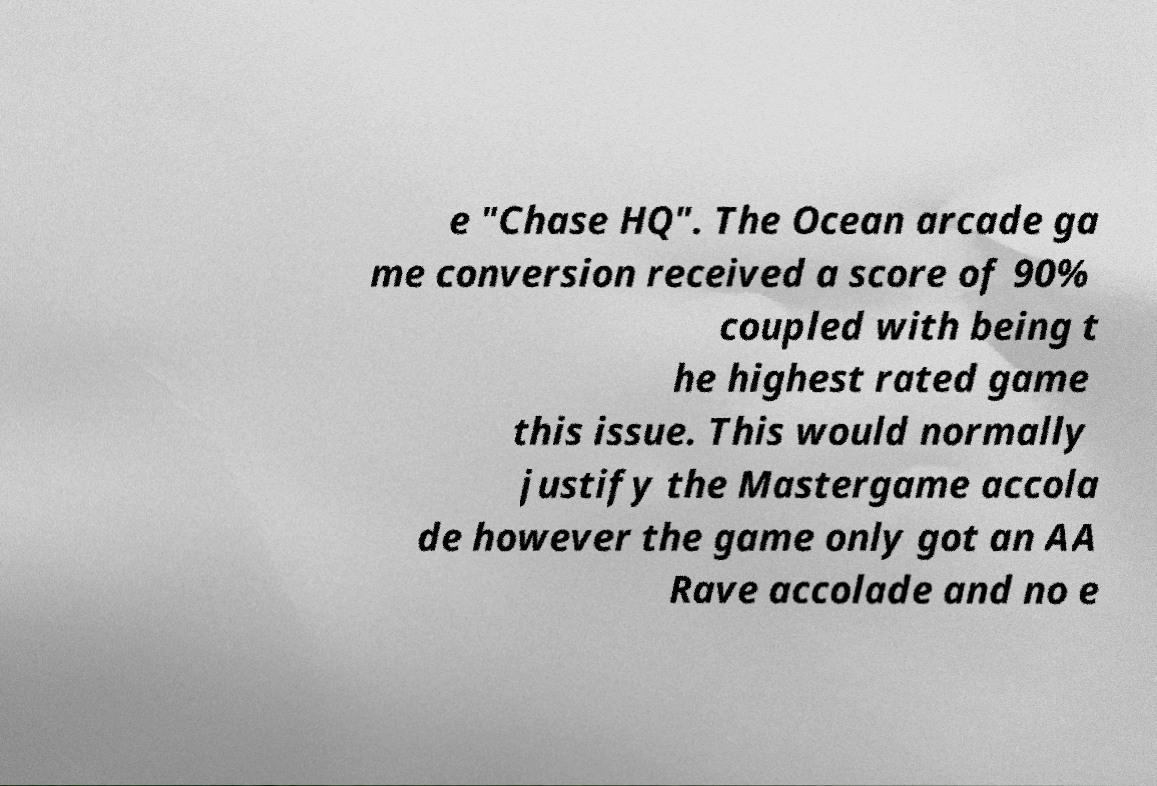Could you extract and type out the text from this image? e "Chase HQ". The Ocean arcade ga me conversion received a score of 90% coupled with being t he highest rated game this issue. This would normally justify the Mastergame accola de however the game only got an AA Rave accolade and no e 